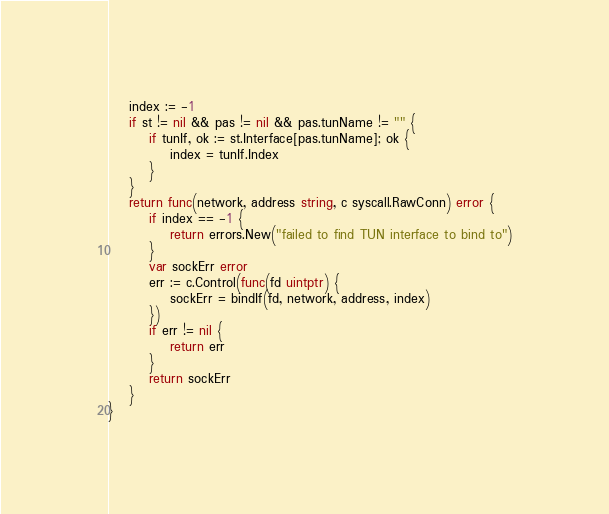Convert code to text. <code><loc_0><loc_0><loc_500><loc_500><_Go_>	index := -1
	if st != nil && pas != nil && pas.tunName != "" {
		if tunIf, ok := st.Interface[pas.tunName]; ok {
			index = tunIf.Index
		}
	}
	return func(network, address string, c syscall.RawConn) error {
		if index == -1 {
			return errors.New("failed to find TUN interface to bind to")
		}
		var sockErr error
		err := c.Control(func(fd uintptr) {
			sockErr = bindIf(fd, network, address, index)
		})
		if err != nil {
			return err
		}
		return sockErr
	}
}
</code> 